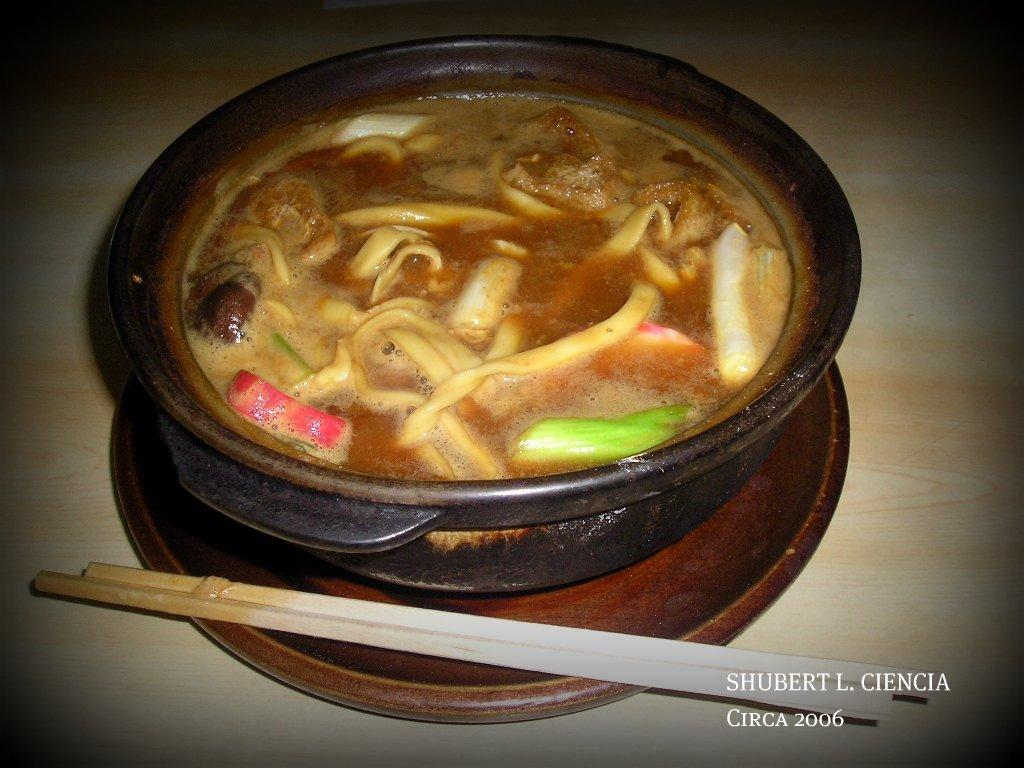What type of dishware can be seen in the image? There is a plate and a bowl in the image. What utensils are visible in the image? Chopsticks are visible in the image. What is the primary purpose of the items in the image? The items in the image are used for serving and eating food. Can you describe the food in the image? There is food in the image, but the specific type of food cannot be determined from the facts provided. Is there any additional information about the image itself? Yes, there is a watermark on the right side bottom of the image. What type of fang can be seen in the image? There is no fang present in the image. Is the dirt visible in the image? The facts provided do not mention any dirt in the image. --- Facts: 1. There is a person sitting on a chair in the image. 2. The person is holding a book. 3. The book has a blue cover. 4. There is a table next to the chair. 5. The table has a lamp on it. Absurd Topics: parrot, sand, bicycle Conversation: What is the person in the image doing? The person in the image is sitting on a chair. What object is the person holding? The person is holding a book. Can you describe the book's appearance? The book has a blue cover. What is located next to the chair in the image? There is a table next to the chair. What item can be seen on the table? The table has a lamp on it. Reasoning: Let's think step by step in order to produce the conversation. We start by identifying the main subject in the image, which is the person sitting on a chair. Then, we expand the conversation to include the book the person is holding, describing its appearance with the information provided. We mention the table next to the chair and the lamp on it as additional details. Absurd Question/Answer: Can you tell me how many parrots are sitting on the person's shoulder in the image? There are no parrots present in the image. Is there any sand visible in the image? The facts provided do not mention any sand in the image. 